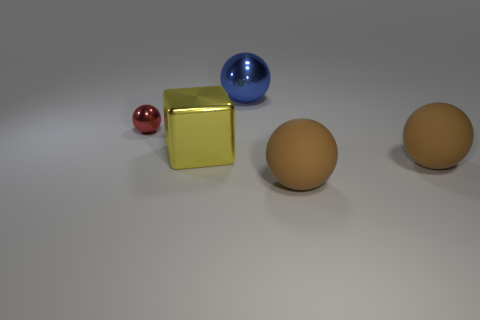Is the number of big blue metallic objects that are in front of the small red shiny thing the same as the number of shiny balls that are in front of the big metal block?
Your answer should be compact. Yes. What color is the big metal object that is behind the large shiny thing that is in front of the large metal object to the right of the large shiny block?
Offer a terse response. Blue. What is the shape of the object behind the tiny ball?
Keep it short and to the point. Sphere. What shape is the big blue object that is the same material as the big yellow block?
Your answer should be very brief. Sphere. Is there anything else that is the same shape as the tiny red metal object?
Ensure brevity in your answer.  Yes. There is a blue shiny thing; how many large metal blocks are behind it?
Your response must be concise. 0. Are there the same number of rubber objects behind the small red metal object and big yellow blocks?
Provide a short and direct response. No. Do the blue sphere and the yellow block have the same material?
Keep it short and to the point. Yes. What size is the object that is both behind the large yellow cube and to the left of the blue shiny thing?
Give a very brief answer. Small. How many brown rubber balls are the same size as the yellow cube?
Your response must be concise. 2. 